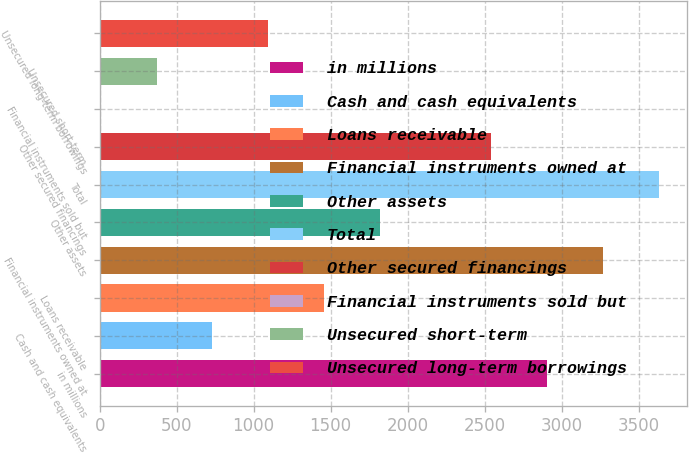Convert chart to OTSL. <chart><loc_0><loc_0><loc_500><loc_500><bar_chart><fcel>in millions<fcel>Cash and cash equivalents<fcel>Loans receivable<fcel>Financial instruments owned at<fcel>Other assets<fcel>Total<fcel>Other secured financings<fcel>Financial instruments sold but<fcel>Unsecured short-term<fcel>Unsecured long-term borrowings<nl><fcel>2907<fcel>732<fcel>1457<fcel>3269.5<fcel>1819.5<fcel>3632<fcel>2544.5<fcel>7<fcel>369.5<fcel>1094.5<nl></chart> 